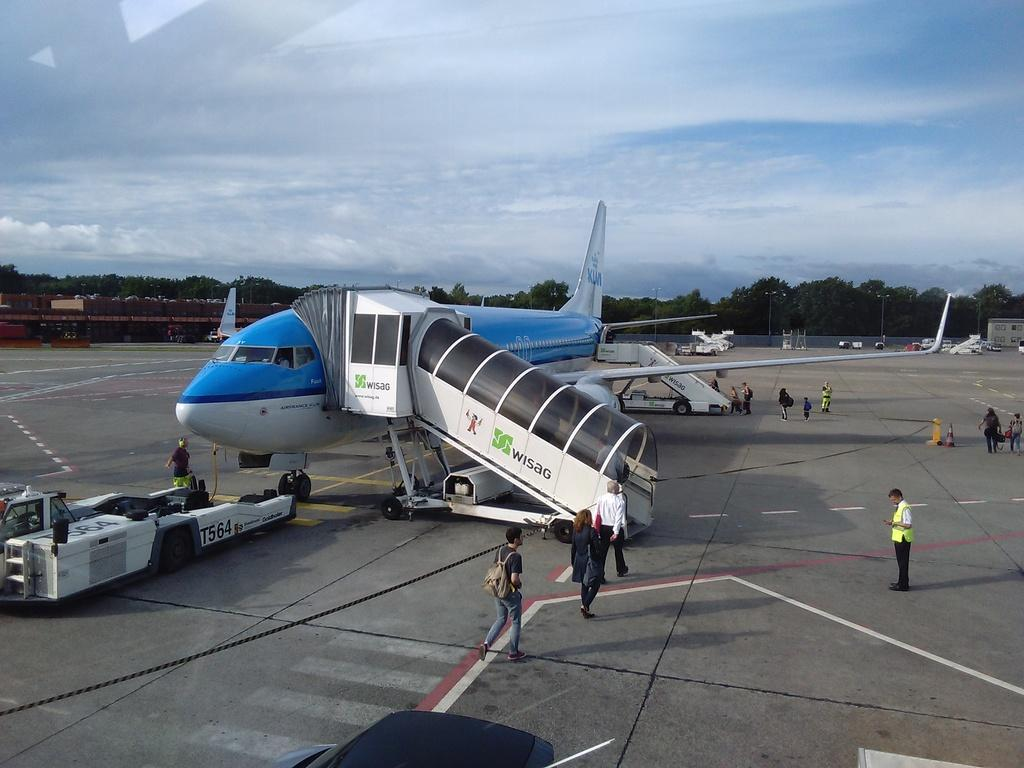<image>
Write a terse but informative summary of the picture. An airplane from the company Air France boarding passengers 